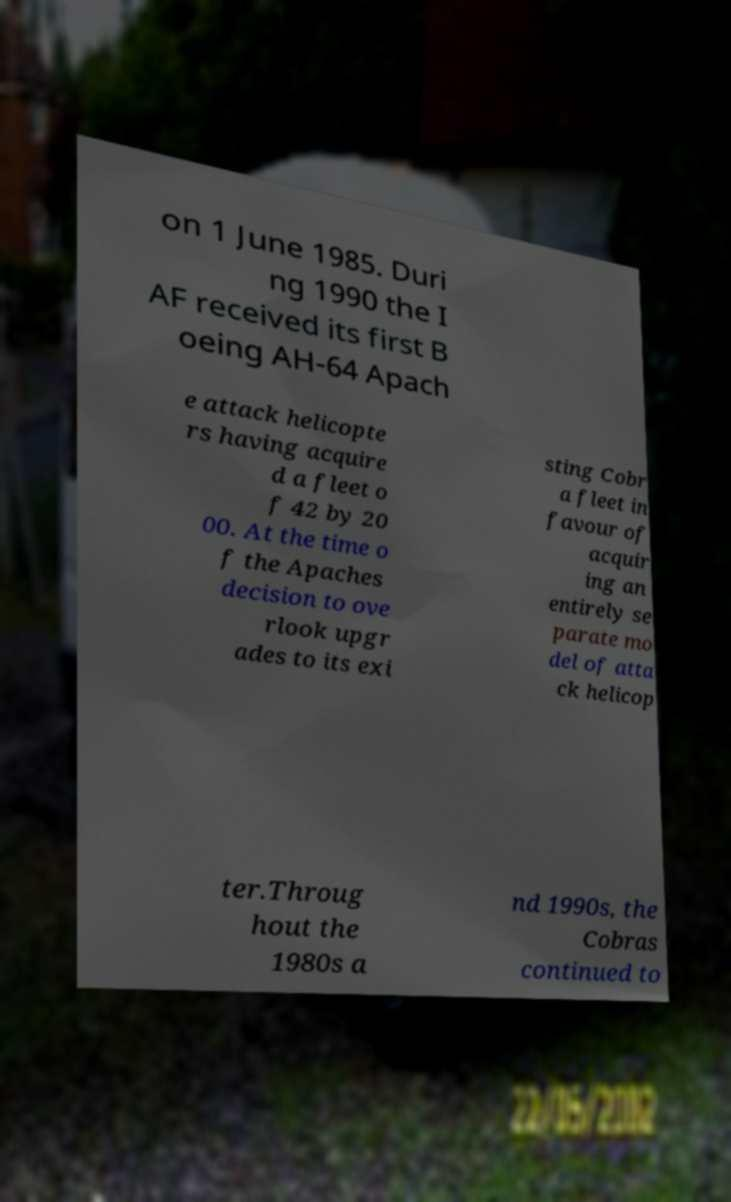I need the written content from this picture converted into text. Can you do that? on 1 June 1985. Duri ng 1990 the I AF received its first B oeing AH-64 Apach e attack helicopte rs having acquire d a fleet o f 42 by 20 00. At the time o f the Apaches decision to ove rlook upgr ades to its exi sting Cobr a fleet in favour of acquir ing an entirely se parate mo del of atta ck helicop ter.Throug hout the 1980s a nd 1990s, the Cobras continued to 